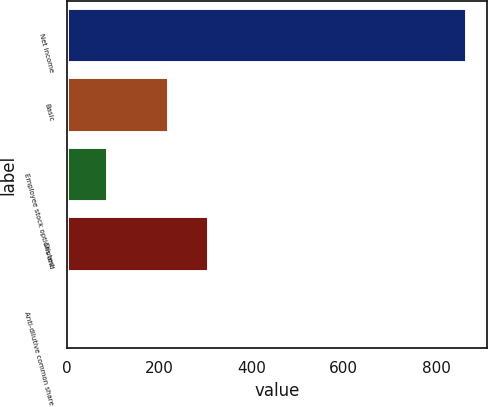Convert chart. <chart><loc_0><loc_0><loc_500><loc_500><bar_chart><fcel>Net income<fcel>Basic<fcel>Employee stock options and<fcel>Diluted<fcel>Anti-dilutive common share<nl><fcel>867<fcel>221<fcel>87.6<fcel>307.6<fcel>1<nl></chart> 